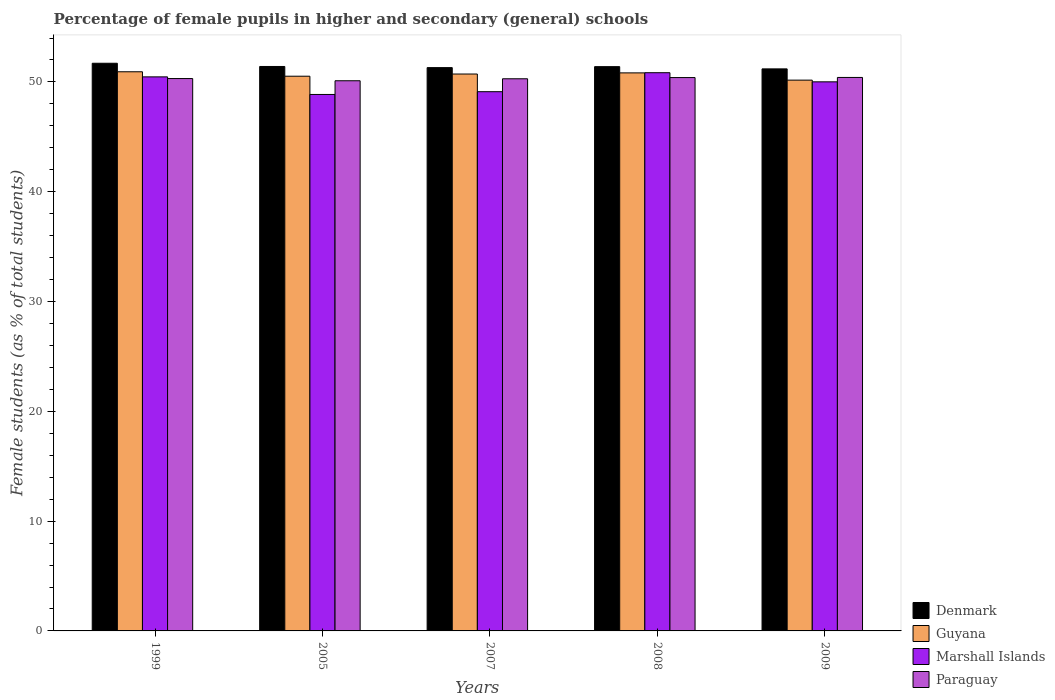How many different coloured bars are there?
Offer a terse response. 4. How many groups of bars are there?
Offer a terse response. 5. How many bars are there on the 3rd tick from the right?
Keep it short and to the point. 4. What is the percentage of female pupils in higher and secondary schools in Marshall Islands in 2007?
Your answer should be very brief. 49.11. Across all years, what is the maximum percentage of female pupils in higher and secondary schools in Paraguay?
Ensure brevity in your answer.  50.41. Across all years, what is the minimum percentage of female pupils in higher and secondary schools in Denmark?
Provide a succinct answer. 51.19. In which year was the percentage of female pupils in higher and secondary schools in Marshall Islands minimum?
Your answer should be very brief. 2005. What is the total percentage of female pupils in higher and secondary schools in Paraguay in the graph?
Offer a very short reply. 251.51. What is the difference between the percentage of female pupils in higher and secondary schools in Paraguay in 1999 and that in 2009?
Offer a very short reply. -0.1. What is the difference between the percentage of female pupils in higher and secondary schools in Guyana in 2005 and the percentage of female pupils in higher and secondary schools in Marshall Islands in 2009?
Offer a very short reply. 0.51. What is the average percentage of female pupils in higher and secondary schools in Denmark per year?
Keep it short and to the point. 51.4. In the year 2005, what is the difference between the percentage of female pupils in higher and secondary schools in Denmark and percentage of female pupils in higher and secondary schools in Guyana?
Make the answer very short. 0.89. In how many years, is the percentage of female pupils in higher and secondary schools in Paraguay greater than 50 %?
Offer a terse response. 5. What is the ratio of the percentage of female pupils in higher and secondary schools in Marshall Islands in 2007 to that in 2009?
Offer a very short reply. 0.98. What is the difference between the highest and the second highest percentage of female pupils in higher and secondary schools in Denmark?
Make the answer very short. 0.29. What is the difference between the highest and the lowest percentage of female pupils in higher and secondary schools in Paraguay?
Give a very brief answer. 0.3. In how many years, is the percentage of female pupils in higher and secondary schools in Paraguay greater than the average percentage of female pupils in higher and secondary schools in Paraguay taken over all years?
Your answer should be compact. 3. Is the sum of the percentage of female pupils in higher and secondary schools in Marshall Islands in 1999 and 2007 greater than the maximum percentage of female pupils in higher and secondary schools in Guyana across all years?
Offer a terse response. Yes. What does the 1st bar from the left in 2005 represents?
Offer a very short reply. Denmark. What does the 1st bar from the right in 2009 represents?
Your response must be concise. Paraguay. Is it the case that in every year, the sum of the percentage of female pupils in higher and secondary schools in Paraguay and percentage of female pupils in higher and secondary schools in Marshall Islands is greater than the percentage of female pupils in higher and secondary schools in Denmark?
Offer a terse response. Yes. How many bars are there?
Provide a short and direct response. 20. Are all the bars in the graph horizontal?
Keep it short and to the point. No. How many years are there in the graph?
Make the answer very short. 5. What is the difference between two consecutive major ticks on the Y-axis?
Give a very brief answer. 10. Does the graph contain any zero values?
Your response must be concise. No. Where does the legend appear in the graph?
Your answer should be compact. Bottom right. How are the legend labels stacked?
Give a very brief answer. Vertical. What is the title of the graph?
Provide a short and direct response. Percentage of female pupils in higher and secondary (general) schools. What is the label or title of the Y-axis?
Offer a very short reply. Female students (as % of total students). What is the Female students (as % of total students) in Denmark in 1999?
Offer a very short reply. 51.7. What is the Female students (as % of total students) in Guyana in 1999?
Offer a terse response. 50.93. What is the Female students (as % of total students) of Marshall Islands in 1999?
Your answer should be compact. 50.46. What is the Female students (as % of total students) of Paraguay in 1999?
Ensure brevity in your answer.  50.31. What is the Female students (as % of total students) of Denmark in 2005?
Provide a short and direct response. 51.41. What is the Female students (as % of total students) of Guyana in 2005?
Provide a succinct answer. 50.52. What is the Female students (as % of total students) in Marshall Islands in 2005?
Provide a short and direct response. 48.86. What is the Female students (as % of total students) of Paraguay in 2005?
Give a very brief answer. 50.11. What is the Female students (as % of total students) of Denmark in 2007?
Offer a terse response. 51.3. What is the Female students (as % of total students) in Guyana in 2007?
Keep it short and to the point. 50.72. What is the Female students (as % of total students) of Marshall Islands in 2007?
Your response must be concise. 49.11. What is the Female students (as % of total students) of Paraguay in 2007?
Provide a succinct answer. 50.29. What is the Female students (as % of total students) of Denmark in 2008?
Your response must be concise. 51.39. What is the Female students (as % of total students) of Guyana in 2008?
Ensure brevity in your answer.  50.82. What is the Female students (as % of total students) of Marshall Islands in 2008?
Give a very brief answer. 50.84. What is the Female students (as % of total students) of Paraguay in 2008?
Give a very brief answer. 50.4. What is the Female students (as % of total students) in Denmark in 2009?
Offer a terse response. 51.19. What is the Female students (as % of total students) in Guyana in 2009?
Your answer should be very brief. 50.16. What is the Female students (as % of total students) of Marshall Islands in 2009?
Provide a short and direct response. 50.01. What is the Female students (as % of total students) in Paraguay in 2009?
Offer a terse response. 50.41. Across all years, what is the maximum Female students (as % of total students) of Denmark?
Provide a succinct answer. 51.7. Across all years, what is the maximum Female students (as % of total students) in Guyana?
Make the answer very short. 50.93. Across all years, what is the maximum Female students (as % of total students) in Marshall Islands?
Give a very brief answer. 50.84. Across all years, what is the maximum Female students (as % of total students) of Paraguay?
Provide a short and direct response. 50.41. Across all years, what is the minimum Female students (as % of total students) of Denmark?
Give a very brief answer. 51.19. Across all years, what is the minimum Female students (as % of total students) in Guyana?
Provide a succinct answer. 50.16. Across all years, what is the minimum Female students (as % of total students) in Marshall Islands?
Your response must be concise. 48.86. Across all years, what is the minimum Female students (as % of total students) in Paraguay?
Your answer should be compact. 50.11. What is the total Female students (as % of total students) of Denmark in the graph?
Your answer should be very brief. 256.99. What is the total Female students (as % of total students) in Guyana in the graph?
Your response must be concise. 253.16. What is the total Female students (as % of total students) in Marshall Islands in the graph?
Your answer should be very brief. 249.28. What is the total Female students (as % of total students) in Paraguay in the graph?
Ensure brevity in your answer.  251.51. What is the difference between the Female students (as % of total students) in Denmark in 1999 and that in 2005?
Offer a terse response. 0.29. What is the difference between the Female students (as % of total students) of Guyana in 1999 and that in 2005?
Provide a short and direct response. 0.41. What is the difference between the Female students (as % of total students) of Marshall Islands in 1999 and that in 2005?
Provide a short and direct response. 1.6. What is the difference between the Female students (as % of total students) of Paraguay in 1999 and that in 2005?
Provide a succinct answer. 0.2. What is the difference between the Female students (as % of total students) in Denmark in 1999 and that in 2007?
Offer a very short reply. 0.4. What is the difference between the Female students (as % of total students) of Guyana in 1999 and that in 2007?
Make the answer very short. 0.21. What is the difference between the Female students (as % of total students) in Marshall Islands in 1999 and that in 2007?
Keep it short and to the point. 1.35. What is the difference between the Female students (as % of total students) in Paraguay in 1999 and that in 2007?
Your answer should be very brief. 0.02. What is the difference between the Female students (as % of total students) of Denmark in 1999 and that in 2008?
Offer a very short reply. 0.31. What is the difference between the Female students (as % of total students) of Guyana in 1999 and that in 2008?
Offer a terse response. 0.1. What is the difference between the Female students (as % of total students) in Marshall Islands in 1999 and that in 2008?
Your response must be concise. -0.38. What is the difference between the Female students (as % of total students) of Paraguay in 1999 and that in 2008?
Your response must be concise. -0.09. What is the difference between the Female students (as % of total students) of Denmark in 1999 and that in 2009?
Make the answer very short. 0.51. What is the difference between the Female students (as % of total students) of Guyana in 1999 and that in 2009?
Give a very brief answer. 0.76. What is the difference between the Female students (as % of total students) in Marshall Islands in 1999 and that in 2009?
Keep it short and to the point. 0.45. What is the difference between the Female students (as % of total students) in Paraguay in 1999 and that in 2009?
Make the answer very short. -0.1. What is the difference between the Female students (as % of total students) of Denmark in 2005 and that in 2007?
Provide a short and direct response. 0.1. What is the difference between the Female students (as % of total students) of Guyana in 2005 and that in 2007?
Offer a very short reply. -0.2. What is the difference between the Female students (as % of total students) of Marshall Islands in 2005 and that in 2007?
Your answer should be very brief. -0.25. What is the difference between the Female students (as % of total students) of Paraguay in 2005 and that in 2007?
Your answer should be compact. -0.18. What is the difference between the Female students (as % of total students) in Denmark in 2005 and that in 2008?
Keep it short and to the point. 0.02. What is the difference between the Female students (as % of total students) of Guyana in 2005 and that in 2008?
Provide a succinct answer. -0.3. What is the difference between the Female students (as % of total students) in Marshall Islands in 2005 and that in 2008?
Your response must be concise. -1.98. What is the difference between the Female students (as % of total students) in Paraguay in 2005 and that in 2008?
Provide a short and direct response. -0.29. What is the difference between the Female students (as % of total students) in Denmark in 2005 and that in 2009?
Provide a succinct answer. 0.22. What is the difference between the Female students (as % of total students) in Guyana in 2005 and that in 2009?
Offer a very short reply. 0.36. What is the difference between the Female students (as % of total students) of Marshall Islands in 2005 and that in 2009?
Ensure brevity in your answer.  -1.15. What is the difference between the Female students (as % of total students) of Paraguay in 2005 and that in 2009?
Your answer should be very brief. -0.3. What is the difference between the Female students (as % of total students) in Denmark in 2007 and that in 2008?
Offer a very short reply. -0.09. What is the difference between the Female students (as % of total students) of Guyana in 2007 and that in 2008?
Your response must be concise. -0.1. What is the difference between the Female students (as % of total students) of Marshall Islands in 2007 and that in 2008?
Make the answer very short. -1.73. What is the difference between the Female students (as % of total students) of Paraguay in 2007 and that in 2008?
Your answer should be compact. -0.11. What is the difference between the Female students (as % of total students) in Denmark in 2007 and that in 2009?
Provide a short and direct response. 0.11. What is the difference between the Female students (as % of total students) of Guyana in 2007 and that in 2009?
Offer a terse response. 0.56. What is the difference between the Female students (as % of total students) in Marshall Islands in 2007 and that in 2009?
Make the answer very short. -0.9. What is the difference between the Female students (as % of total students) in Paraguay in 2007 and that in 2009?
Offer a terse response. -0.12. What is the difference between the Female students (as % of total students) in Denmark in 2008 and that in 2009?
Give a very brief answer. 0.2. What is the difference between the Female students (as % of total students) in Guyana in 2008 and that in 2009?
Give a very brief answer. 0.66. What is the difference between the Female students (as % of total students) of Marshall Islands in 2008 and that in 2009?
Keep it short and to the point. 0.83. What is the difference between the Female students (as % of total students) of Paraguay in 2008 and that in 2009?
Provide a short and direct response. -0.01. What is the difference between the Female students (as % of total students) in Denmark in 1999 and the Female students (as % of total students) in Guyana in 2005?
Your answer should be very brief. 1.18. What is the difference between the Female students (as % of total students) in Denmark in 1999 and the Female students (as % of total students) in Marshall Islands in 2005?
Your answer should be very brief. 2.84. What is the difference between the Female students (as % of total students) in Denmark in 1999 and the Female students (as % of total students) in Paraguay in 2005?
Ensure brevity in your answer.  1.59. What is the difference between the Female students (as % of total students) in Guyana in 1999 and the Female students (as % of total students) in Marshall Islands in 2005?
Provide a succinct answer. 2.07. What is the difference between the Female students (as % of total students) of Guyana in 1999 and the Female students (as % of total students) of Paraguay in 2005?
Provide a succinct answer. 0.82. What is the difference between the Female students (as % of total students) of Marshall Islands in 1999 and the Female students (as % of total students) of Paraguay in 2005?
Offer a terse response. 0.35. What is the difference between the Female students (as % of total students) in Denmark in 1999 and the Female students (as % of total students) in Guyana in 2007?
Keep it short and to the point. 0.98. What is the difference between the Female students (as % of total students) in Denmark in 1999 and the Female students (as % of total students) in Marshall Islands in 2007?
Ensure brevity in your answer.  2.59. What is the difference between the Female students (as % of total students) of Denmark in 1999 and the Female students (as % of total students) of Paraguay in 2007?
Keep it short and to the point. 1.41. What is the difference between the Female students (as % of total students) in Guyana in 1999 and the Female students (as % of total students) in Marshall Islands in 2007?
Your answer should be very brief. 1.82. What is the difference between the Female students (as % of total students) in Guyana in 1999 and the Female students (as % of total students) in Paraguay in 2007?
Make the answer very short. 0.64. What is the difference between the Female students (as % of total students) in Marshall Islands in 1999 and the Female students (as % of total students) in Paraguay in 2007?
Provide a succinct answer. 0.17. What is the difference between the Female students (as % of total students) in Denmark in 1999 and the Female students (as % of total students) in Guyana in 2008?
Your answer should be compact. 0.88. What is the difference between the Female students (as % of total students) in Denmark in 1999 and the Female students (as % of total students) in Marshall Islands in 2008?
Provide a succinct answer. 0.86. What is the difference between the Female students (as % of total students) in Denmark in 1999 and the Female students (as % of total students) in Paraguay in 2008?
Your answer should be very brief. 1.3. What is the difference between the Female students (as % of total students) in Guyana in 1999 and the Female students (as % of total students) in Marshall Islands in 2008?
Your answer should be compact. 0.09. What is the difference between the Female students (as % of total students) of Guyana in 1999 and the Female students (as % of total students) of Paraguay in 2008?
Keep it short and to the point. 0.53. What is the difference between the Female students (as % of total students) in Marshall Islands in 1999 and the Female students (as % of total students) in Paraguay in 2008?
Make the answer very short. 0.06. What is the difference between the Female students (as % of total students) of Denmark in 1999 and the Female students (as % of total students) of Guyana in 2009?
Keep it short and to the point. 1.54. What is the difference between the Female students (as % of total students) in Denmark in 1999 and the Female students (as % of total students) in Marshall Islands in 2009?
Offer a terse response. 1.69. What is the difference between the Female students (as % of total students) in Denmark in 1999 and the Female students (as % of total students) in Paraguay in 2009?
Your response must be concise. 1.29. What is the difference between the Female students (as % of total students) in Guyana in 1999 and the Female students (as % of total students) in Marshall Islands in 2009?
Make the answer very short. 0.92. What is the difference between the Female students (as % of total students) of Guyana in 1999 and the Female students (as % of total students) of Paraguay in 2009?
Offer a very short reply. 0.52. What is the difference between the Female students (as % of total students) in Marshall Islands in 1999 and the Female students (as % of total students) in Paraguay in 2009?
Keep it short and to the point. 0.05. What is the difference between the Female students (as % of total students) of Denmark in 2005 and the Female students (as % of total students) of Guyana in 2007?
Keep it short and to the point. 0.69. What is the difference between the Female students (as % of total students) in Denmark in 2005 and the Female students (as % of total students) in Marshall Islands in 2007?
Your response must be concise. 2.3. What is the difference between the Female students (as % of total students) in Denmark in 2005 and the Female students (as % of total students) in Paraguay in 2007?
Ensure brevity in your answer.  1.12. What is the difference between the Female students (as % of total students) in Guyana in 2005 and the Female students (as % of total students) in Marshall Islands in 2007?
Offer a very short reply. 1.41. What is the difference between the Female students (as % of total students) of Guyana in 2005 and the Female students (as % of total students) of Paraguay in 2007?
Offer a very short reply. 0.23. What is the difference between the Female students (as % of total students) of Marshall Islands in 2005 and the Female students (as % of total students) of Paraguay in 2007?
Provide a short and direct response. -1.43. What is the difference between the Female students (as % of total students) of Denmark in 2005 and the Female students (as % of total students) of Guyana in 2008?
Provide a succinct answer. 0.58. What is the difference between the Female students (as % of total students) of Denmark in 2005 and the Female students (as % of total students) of Marshall Islands in 2008?
Keep it short and to the point. 0.57. What is the difference between the Female students (as % of total students) in Denmark in 2005 and the Female students (as % of total students) in Paraguay in 2008?
Offer a terse response. 1.01. What is the difference between the Female students (as % of total students) in Guyana in 2005 and the Female students (as % of total students) in Marshall Islands in 2008?
Your response must be concise. -0.32. What is the difference between the Female students (as % of total students) of Guyana in 2005 and the Female students (as % of total students) of Paraguay in 2008?
Offer a very short reply. 0.12. What is the difference between the Female students (as % of total students) of Marshall Islands in 2005 and the Female students (as % of total students) of Paraguay in 2008?
Give a very brief answer. -1.54. What is the difference between the Female students (as % of total students) of Denmark in 2005 and the Female students (as % of total students) of Guyana in 2009?
Keep it short and to the point. 1.24. What is the difference between the Female students (as % of total students) in Denmark in 2005 and the Female students (as % of total students) in Marshall Islands in 2009?
Provide a succinct answer. 1.4. What is the difference between the Female students (as % of total students) in Denmark in 2005 and the Female students (as % of total students) in Paraguay in 2009?
Provide a short and direct response. 1. What is the difference between the Female students (as % of total students) in Guyana in 2005 and the Female students (as % of total students) in Marshall Islands in 2009?
Give a very brief answer. 0.51. What is the difference between the Female students (as % of total students) of Guyana in 2005 and the Female students (as % of total students) of Paraguay in 2009?
Offer a terse response. 0.11. What is the difference between the Female students (as % of total students) in Marshall Islands in 2005 and the Female students (as % of total students) in Paraguay in 2009?
Offer a terse response. -1.55. What is the difference between the Female students (as % of total students) in Denmark in 2007 and the Female students (as % of total students) in Guyana in 2008?
Your response must be concise. 0.48. What is the difference between the Female students (as % of total students) of Denmark in 2007 and the Female students (as % of total students) of Marshall Islands in 2008?
Give a very brief answer. 0.46. What is the difference between the Female students (as % of total students) in Denmark in 2007 and the Female students (as % of total students) in Paraguay in 2008?
Give a very brief answer. 0.91. What is the difference between the Female students (as % of total students) in Guyana in 2007 and the Female students (as % of total students) in Marshall Islands in 2008?
Offer a very short reply. -0.12. What is the difference between the Female students (as % of total students) of Guyana in 2007 and the Female students (as % of total students) of Paraguay in 2008?
Your answer should be compact. 0.32. What is the difference between the Female students (as % of total students) of Marshall Islands in 2007 and the Female students (as % of total students) of Paraguay in 2008?
Your response must be concise. -1.29. What is the difference between the Female students (as % of total students) in Denmark in 2007 and the Female students (as % of total students) in Guyana in 2009?
Give a very brief answer. 1.14. What is the difference between the Female students (as % of total students) of Denmark in 2007 and the Female students (as % of total students) of Marshall Islands in 2009?
Ensure brevity in your answer.  1.29. What is the difference between the Female students (as % of total students) in Denmark in 2007 and the Female students (as % of total students) in Paraguay in 2009?
Offer a terse response. 0.89. What is the difference between the Female students (as % of total students) of Guyana in 2007 and the Female students (as % of total students) of Marshall Islands in 2009?
Ensure brevity in your answer.  0.71. What is the difference between the Female students (as % of total students) in Guyana in 2007 and the Female students (as % of total students) in Paraguay in 2009?
Keep it short and to the point. 0.31. What is the difference between the Female students (as % of total students) of Marshall Islands in 2007 and the Female students (as % of total students) of Paraguay in 2009?
Your answer should be very brief. -1.3. What is the difference between the Female students (as % of total students) in Denmark in 2008 and the Female students (as % of total students) in Guyana in 2009?
Your response must be concise. 1.23. What is the difference between the Female students (as % of total students) in Denmark in 2008 and the Female students (as % of total students) in Marshall Islands in 2009?
Make the answer very short. 1.38. What is the difference between the Female students (as % of total students) of Denmark in 2008 and the Female students (as % of total students) of Paraguay in 2009?
Make the answer very short. 0.98. What is the difference between the Female students (as % of total students) in Guyana in 2008 and the Female students (as % of total students) in Marshall Islands in 2009?
Give a very brief answer. 0.81. What is the difference between the Female students (as % of total students) in Guyana in 2008 and the Female students (as % of total students) in Paraguay in 2009?
Provide a short and direct response. 0.41. What is the difference between the Female students (as % of total students) of Marshall Islands in 2008 and the Female students (as % of total students) of Paraguay in 2009?
Your answer should be compact. 0.43. What is the average Female students (as % of total students) of Denmark per year?
Offer a terse response. 51.4. What is the average Female students (as % of total students) of Guyana per year?
Provide a short and direct response. 50.63. What is the average Female students (as % of total students) of Marshall Islands per year?
Provide a short and direct response. 49.86. What is the average Female students (as % of total students) in Paraguay per year?
Make the answer very short. 50.3. In the year 1999, what is the difference between the Female students (as % of total students) of Denmark and Female students (as % of total students) of Guyana?
Offer a very short reply. 0.78. In the year 1999, what is the difference between the Female students (as % of total students) of Denmark and Female students (as % of total students) of Marshall Islands?
Provide a succinct answer. 1.24. In the year 1999, what is the difference between the Female students (as % of total students) in Denmark and Female students (as % of total students) in Paraguay?
Provide a short and direct response. 1.39. In the year 1999, what is the difference between the Female students (as % of total students) in Guyana and Female students (as % of total students) in Marshall Islands?
Your answer should be very brief. 0.46. In the year 1999, what is the difference between the Female students (as % of total students) in Guyana and Female students (as % of total students) in Paraguay?
Offer a very short reply. 0.62. In the year 1999, what is the difference between the Female students (as % of total students) of Marshall Islands and Female students (as % of total students) of Paraguay?
Make the answer very short. 0.15. In the year 2005, what is the difference between the Female students (as % of total students) of Denmark and Female students (as % of total students) of Guyana?
Keep it short and to the point. 0.89. In the year 2005, what is the difference between the Female students (as % of total students) in Denmark and Female students (as % of total students) in Marshall Islands?
Offer a very short reply. 2.55. In the year 2005, what is the difference between the Female students (as % of total students) of Denmark and Female students (as % of total students) of Paraguay?
Your answer should be compact. 1.3. In the year 2005, what is the difference between the Female students (as % of total students) in Guyana and Female students (as % of total students) in Marshall Islands?
Offer a very short reply. 1.66. In the year 2005, what is the difference between the Female students (as % of total students) of Guyana and Female students (as % of total students) of Paraguay?
Make the answer very short. 0.41. In the year 2005, what is the difference between the Female students (as % of total students) of Marshall Islands and Female students (as % of total students) of Paraguay?
Provide a succinct answer. -1.25. In the year 2007, what is the difference between the Female students (as % of total students) of Denmark and Female students (as % of total students) of Guyana?
Your answer should be compact. 0.58. In the year 2007, what is the difference between the Female students (as % of total students) of Denmark and Female students (as % of total students) of Marshall Islands?
Your answer should be compact. 2.19. In the year 2007, what is the difference between the Female students (as % of total students) in Guyana and Female students (as % of total students) in Marshall Islands?
Your response must be concise. 1.61. In the year 2007, what is the difference between the Female students (as % of total students) of Guyana and Female students (as % of total students) of Paraguay?
Your answer should be compact. 0.43. In the year 2007, what is the difference between the Female students (as % of total students) of Marshall Islands and Female students (as % of total students) of Paraguay?
Ensure brevity in your answer.  -1.18. In the year 2008, what is the difference between the Female students (as % of total students) in Denmark and Female students (as % of total students) in Guyana?
Provide a short and direct response. 0.57. In the year 2008, what is the difference between the Female students (as % of total students) of Denmark and Female students (as % of total students) of Marshall Islands?
Provide a succinct answer. 0.55. In the year 2008, what is the difference between the Female students (as % of total students) in Denmark and Female students (as % of total students) in Paraguay?
Offer a very short reply. 0.99. In the year 2008, what is the difference between the Female students (as % of total students) in Guyana and Female students (as % of total students) in Marshall Islands?
Provide a succinct answer. -0.02. In the year 2008, what is the difference between the Female students (as % of total students) in Guyana and Female students (as % of total students) in Paraguay?
Keep it short and to the point. 0.43. In the year 2008, what is the difference between the Female students (as % of total students) in Marshall Islands and Female students (as % of total students) in Paraguay?
Ensure brevity in your answer.  0.44. In the year 2009, what is the difference between the Female students (as % of total students) in Denmark and Female students (as % of total students) in Guyana?
Make the answer very short. 1.02. In the year 2009, what is the difference between the Female students (as % of total students) in Denmark and Female students (as % of total students) in Marshall Islands?
Provide a succinct answer. 1.18. In the year 2009, what is the difference between the Female students (as % of total students) of Denmark and Female students (as % of total students) of Paraguay?
Your answer should be compact. 0.78. In the year 2009, what is the difference between the Female students (as % of total students) in Guyana and Female students (as % of total students) in Marshall Islands?
Keep it short and to the point. 0.15. In the year 2009, what is the difference between the Female students (as % of total students) in Guyana and Female students (as % of total students) in Paraguay?
Provide a succinct answer. -0.25. In the year 2009, what is the difference between the Female students (as % of total students) in Marshall Islands and Female students (as % of total students) in Paraguay?
Ensure brevity in your answer.  -0.4. What is the ratio of the Female students (as % of total students) of Marshall Islands in 1999 to that in 2005?
Your answer should be compact. 1.03. What is the ratio of the Female students (as % of total students) of Paraguay in 1999 to that in 2005?
Offer a terse response. 1. What is the ratio of the Female students (as % of total students) in Marshall Islands in 1999 to that in 2007?
Offer a very short reply. 1.03. What is the ratio of the Female students (as % of total students) of Guyana in 1999 to that in 2008?
Provide a succinct answer. 1. What is the ratio of the Female students (as % of total students) of Paraguay in 1999 to that in 2008?
Keep it short and to the point. 1. What is the ratio of the Female students (as % of total students) of Denmark in 1999 to that in 2009?
Keep it short and to the point. 1.01. What is the ratio of the Female students (as % of total students) of Guyana in 1999 to that in 2009?
Give a very brief answer. 1.02. What is the ratio of the Female students (as % of total students) of Marshall Islands in 1999 to that in 2009?
Keep it short and to the point. 1.01. What is the ratio of the Female students (as % of total students) of Marshall Islands in 2005 to that in 2007?
Provide a succinct answer. 0.99. What is the ratio of the Female students (as % of total students) in Paraguay in 2005 to that in 2007?
Offer a terse response. 1. What is the ratio of the Female students (as % of total students) in Denmark in 2005 to that in 2008?
Keep it short and to the point. 1. What is the ratio of the Female students (as % of total students) of Guyana in 2005 to that in 2008?
Ensure brevity in your answer.  0.99. What is the ratio of the Female students (as % of total students) of Marshall Islands in 2005 to that in 2008?
Give a very brief answer. 0.96. What is the ratio of the Female students (as % of total students) in Paraguay in 2005 to that in 2008?
Make the answer very short. 0.99. What is the ratio of the Female students (as % of total students) of Guyana in 2005 to that in 2009?
Offer a very short reply. 1.01. What is the ratio of the Female students (as % of total students) of Marshall Islands in 2005 to that in 2009?
Offer a terse response. 0.98. What is the ratio of the Female students (as % of total students) in Paraguay in 2005 to that in 2009?
Provide a succinct answer. 0.99. What is the ratio of the Female students (as % of total students) of Marshall Islands in 2007 to that in 2008?
Your response must be concise. 0.97. What is the ratio of the Female students (as % of total students) in Guyana in 2007 to that in 2009?
Offer a terse response. 1.01. What is the ratio of the Female students (as % of total students) of Marshall Islands in 2007 to that in 2009?
Your answer should be compact. 0.98. What is the ratio of the Female students (as % of total students) in Denmark in 2008 to that in 2009?
Make the answer very short. 1. What is the ratio of the Female students (as % of total students) in Guyana in 2008 to that in 2009?
Offer a very short reply. 1.01. What is the ratio of the Female students (as % of total students) of Marshall Islands in 2008 to that in 2009?
Give a very brief answer. 1.02. What is the difference between the highest and the second highest Female students (as % of total students) in Denmark?
Provide a short and direct response. 0.29. What is the difference between the highest and the second highest Female students (as % of total students) in Guyana?
Your answer should be compact. 0.1. What is the difference between the highest and the second highest Female students (as % of total students) of Marshall Islands?
Your response must be concise. 0.38. What is the difference between the highest and the second highest Female students (as % of total students) of Paraguay?
Give a very brief answer. 0.01. What is the difference between the highest and the lowest Female students (as % of total students) of Denmark?
Your answer should be compact. 0.51. What is the difference between the highest and the lowest Female students (as % of total students) in Guyana?
Your answer should be compact. 0.76. What is the difference between the highest and the lowest Female students (as % of total students) in Marshall Islands?
Offer a terse response. 1.98. What is the difference between the highest and the lowest Female students (as % of total students) in Paraguay?
Provide a short and direct response. 0.3. 